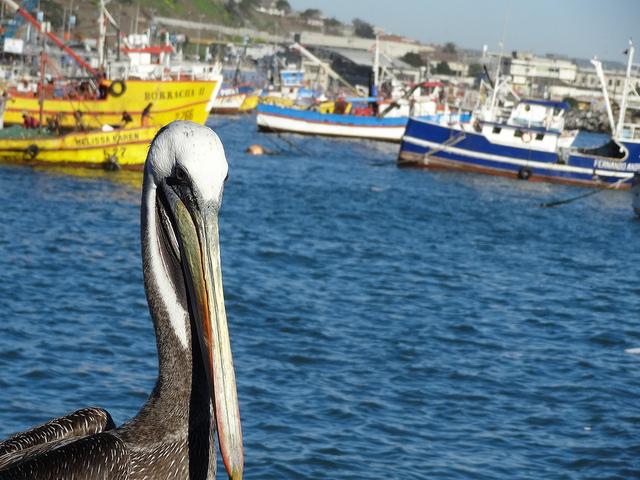What type of bird is this?
Concise answer only. Pelican. Is that bird hungry?
Answer briefly. Yes. What color is the water?
Give a very brief answer. Blue. 